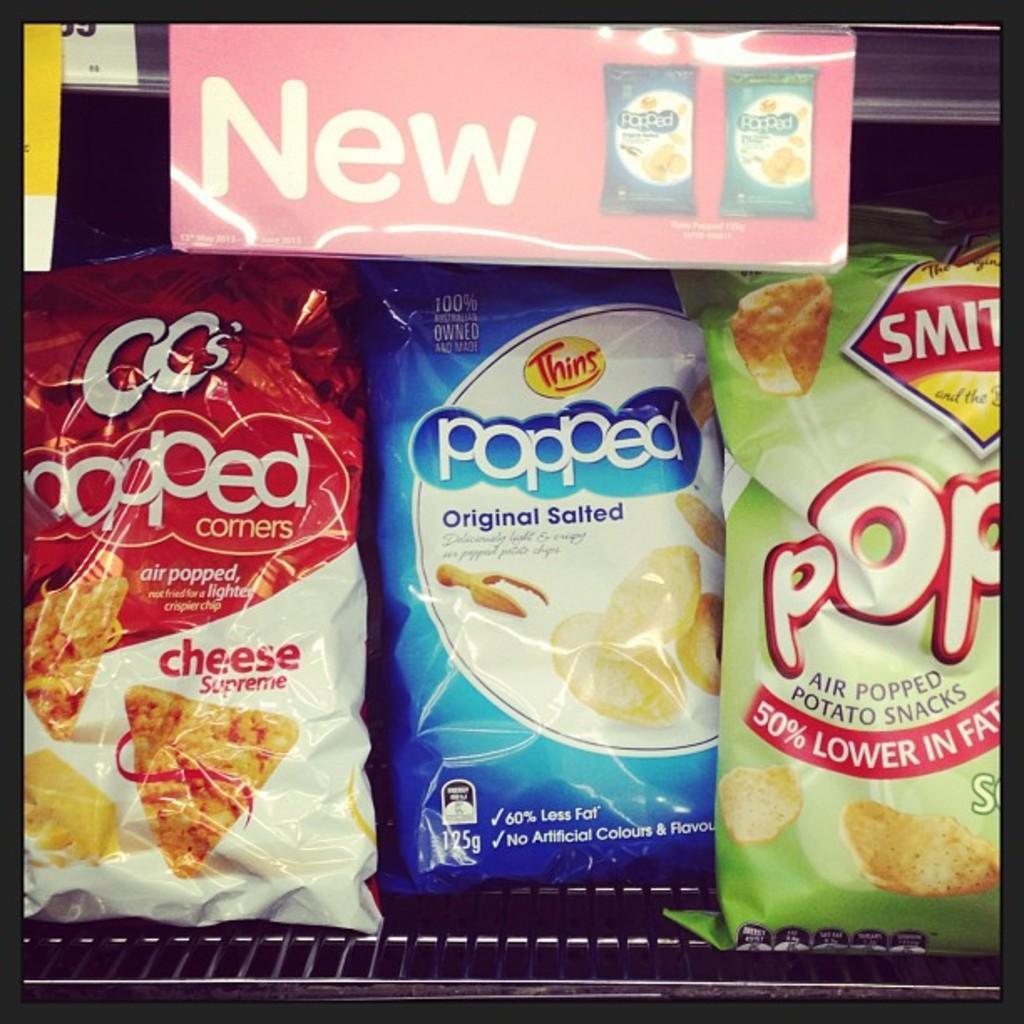Please provide a concise description of this image. In this picture there are some chips packets placed in the refrigerator. 